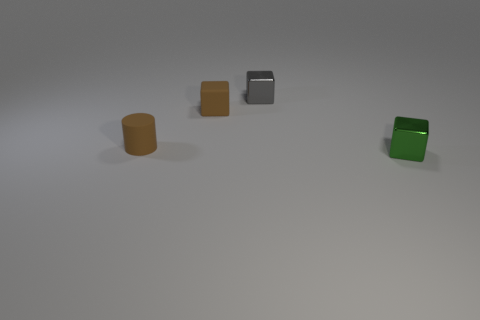What number of gray objects have the same shape as the small green thing?
Make the answer very short. 1. There is a object that is the same color as the cylinder; what is it made of?
Offer a terse response. Rubber. What material is the brown thing that is the same shape as the tiny gray shiny object?
Make the answer very short. Rubber. Are there fewer tiny shiny things on the left side of the small green thing than small gray things that are on the left side of the small gray metal object?
Ensure brevity in your answer.  No. What number of gray shiny things are there?
Offer a very short reply. 1. There is a small shiny thing that is in front of the brown cube; what color is it?
Provide a short and direct response. Green. How big is the green block?
Your answer should be very brief. Small. There is a matte cylinder; does it have the same color as the tiny rubber block that is behind the small green block?
Ensure brevity in your answer.  Yes. What is the color of the small metallic cube that is behind the small cube on the left side of the gray shiny object?
Make the answer very short. Gray. Is there any other thing that is the same size as the green cube?
Your answer should be compact. Yes. 